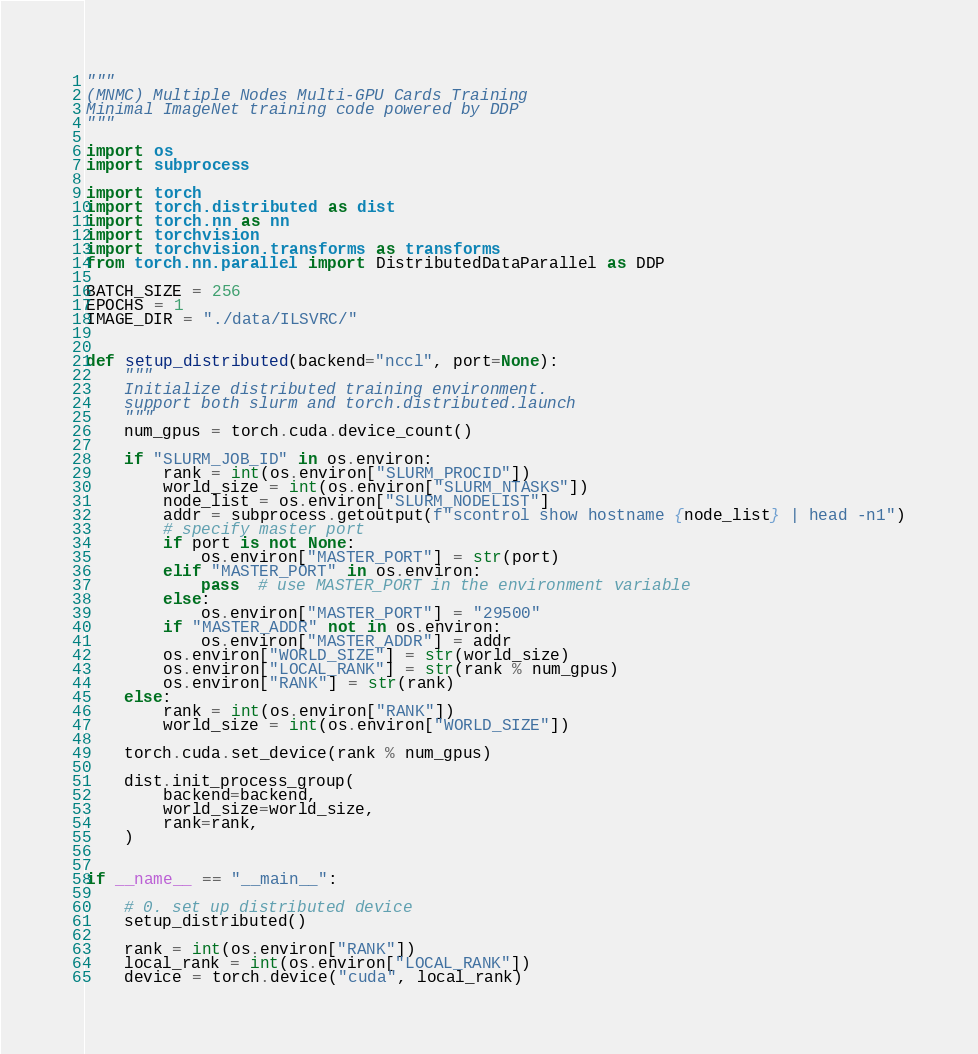<code> <loc_0><loc_0><loc_500><loc_500><_Python_>"""
(MNMC) Multiple Nodes Multi-GPU Cards Training
Minimal ImageNet training code powered by DDP
"""

import os
import subprocess

import torch
import torch.distributed as dist
import torch.nn as nn
import torchvision
import torchvision.transforms as transforms
from torch.nn.parallel import DistributedDataParallel as DDP

BATCH_SIZE = 256
EPOCHS = 1
IMAGE_DIR = "./data/ILSVRC/"


def setup_distributed(backend="nccl", port=None):
    """
    Initialize distributed training environment.
    support both slurm and torch.distributed.launch
    """
    num_gpus = torch.cuda.device_count()

    if "SLURM_JOB_ID" in os.environ:
        rank = int(os.environ["SLURM_PROCID"])
        world_size = int(os.environ["SLURM_NTASKS"])
        node_list = os.environ["SLURM_NODELIST"]
        addr = subprocess.getoutput(f"scontrol show hostname {node_list} | head -n1")
        # specify master port
        if port is not None:
            os.environ["MASTER_PORT"] = str(port)
        elif "MASTER_PORT" in os.environ:
            pass  # use MASTER_PORT in the environment variable
        else:
            os.environ["MASTER_PORT"] = "29500"
        if "MASTER_ADDR" not in os.environ:
            os.environ["MASTER_ADDR"] = addr
        os.environ["WORLD_SIZE"] = str(world_size)
        os.environ["LOCAL_RANK"] = str(rank % num_gpus)
        os.environ["RANK"] = str(rank)
    else:
        rank = int(os.environ["RANK"])
        world_size = int(os.environ["WORLD_SIZE"])

    torch.cuda.set_device(rank % num_gpus)

    dist.init_process_group(
        backend=backend,
        world_size=world_size,
        rank=rank,
    )


if __name__ == "__main__":

    # 0. set up distributed device
    setup_distributed()

    rank = int(os.environ["RANK"])
    local_rank = int(os.environ["LOCAL_RANK"])
    device = torch.device("cuda", local_rank)
</code> 